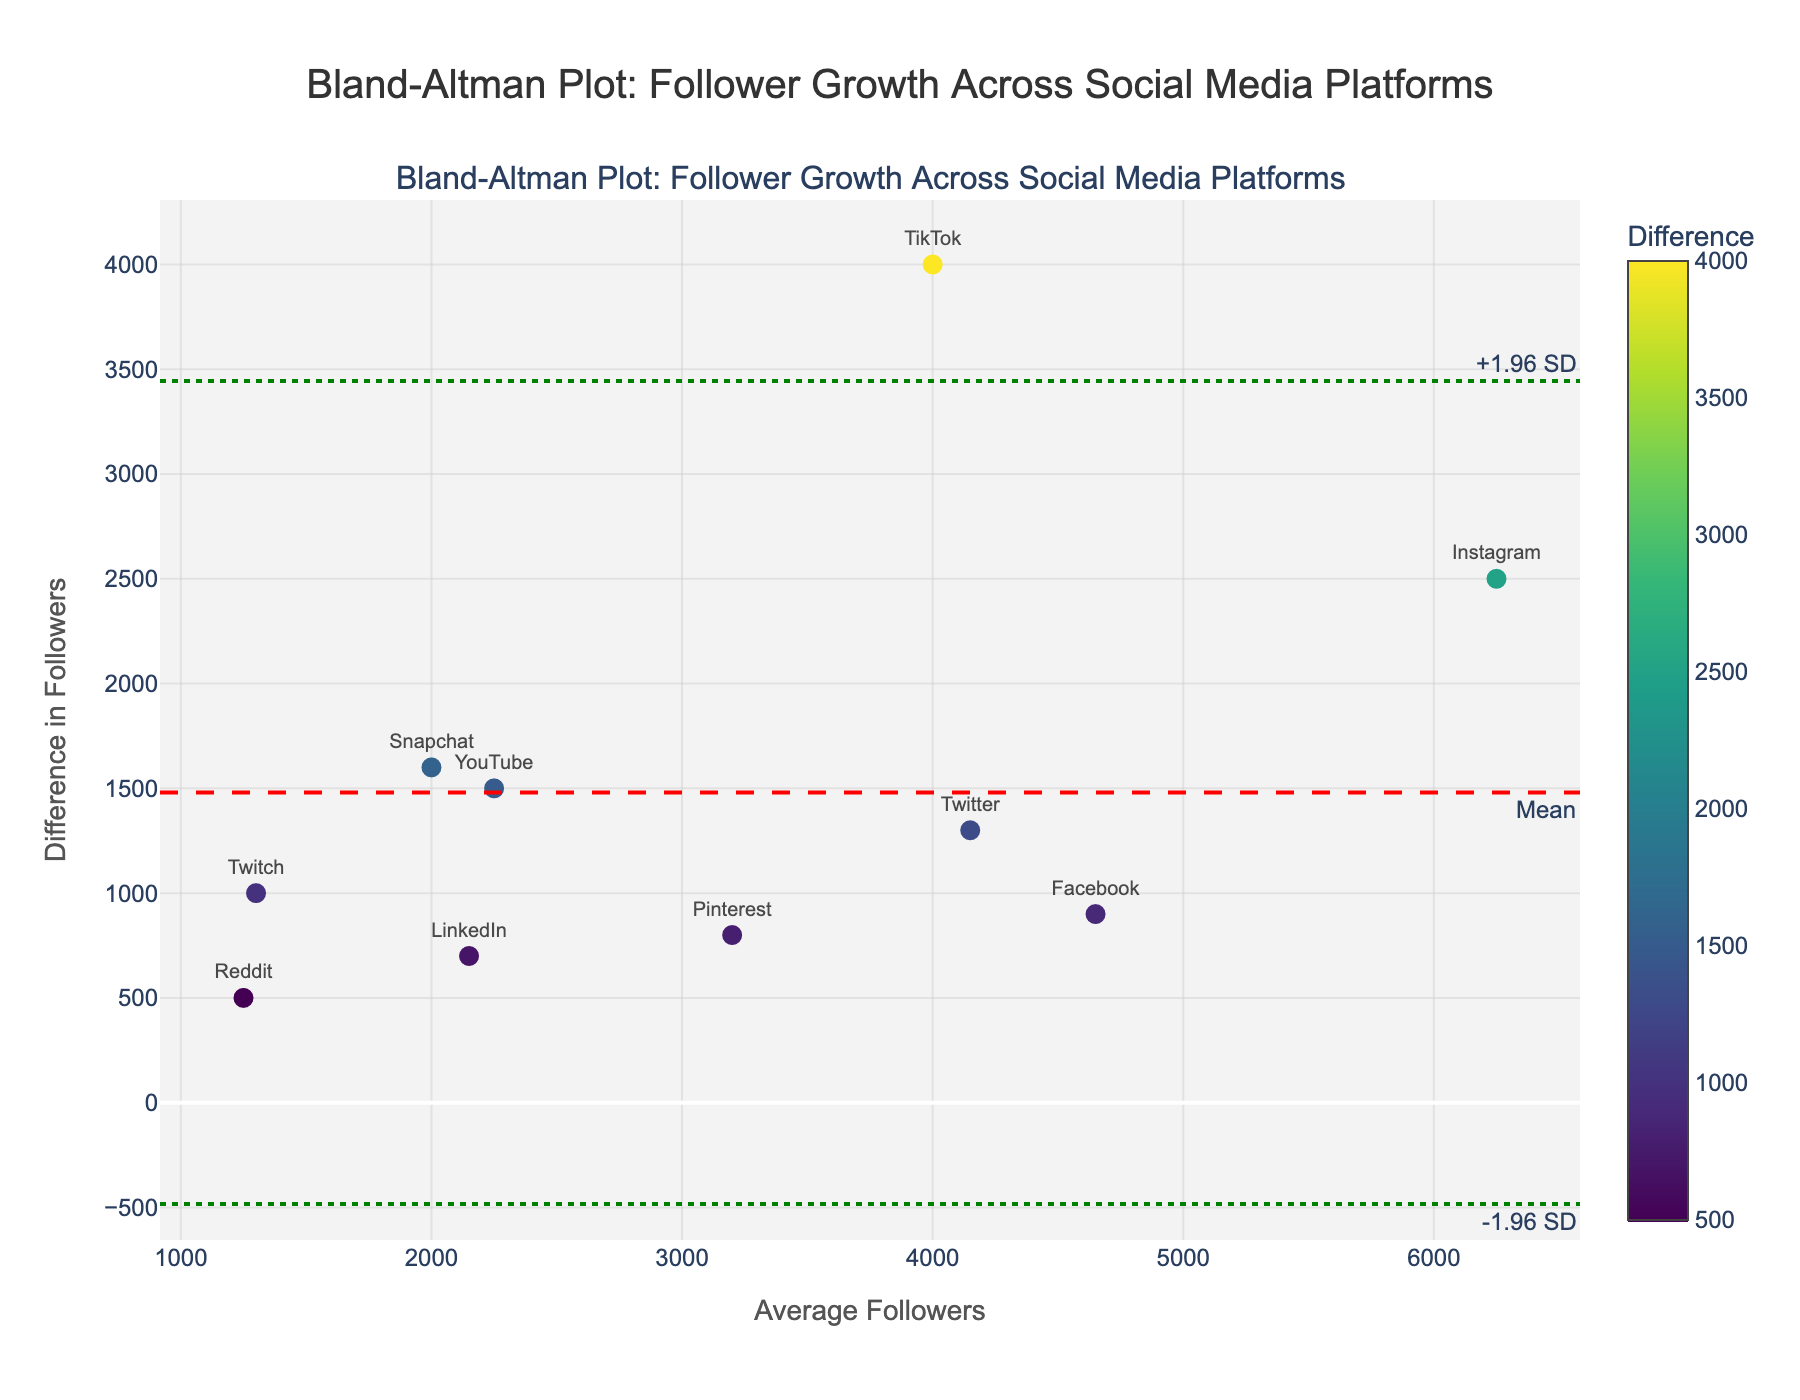What does the Bland-Altman plot title say? The title is located at the top of the plot and reads "Bland-Altman Plot: Follower Growth Across Social Media Platforms."
Answer: Bland-Altman Plot: Follower Growth Across Social Media Platforms How many platforms are represented in the plot? Each marker on the plot represents one platform. There are 10 different markers labeled with different platform names.
Answer: 10 What platform has the highest difference in follower growth? The platform label for the highest marker on the y-axis depicts the highest difference in follower growth. In this case, it is TikTok.
Answer: TikTok What are the units on the y-axis? The y-axis title indicates that the units are related to the "Difference in Followers."
Answer: Difference in Followers Which platform has the smallest difference in follower growth? The marker closest to the bottom of the y-axis represents the smallest difference, labeled as Reddit in this case.
Answer: Reddit How is the average number of followers represented in the plot? The average number of followers for each platform is represented on the x-axis of the plot.
Answer: x-axis What color represents the difference values in the plot? The difference values are shown in various colors based on a color scale from light to dark tones of the 'Viridis' colors. This is indicated by the color bar to the right of the plot named "Difference."
Answer: Viridis colors What does the red dashed line represent? The red dashed line is located at a specific y-value and is labeled "Mean," indicating the average difference across all platforms.
Answer: Mean difference What do the green dotted lines represent? There are two green dotted lines, one above the mean and one below the mean. They are labeled "+1.96 SD" and "-1.96 SD," respectively. These lines represent the mean difference plus and minus 1.96 times the standard deviation.
Answer: 1.96 SD above and below the mean Which platform has an average follower count around 4000? The marker near the x-axis value of 4000 is labeled as Twitter.
Answer: Twitter 